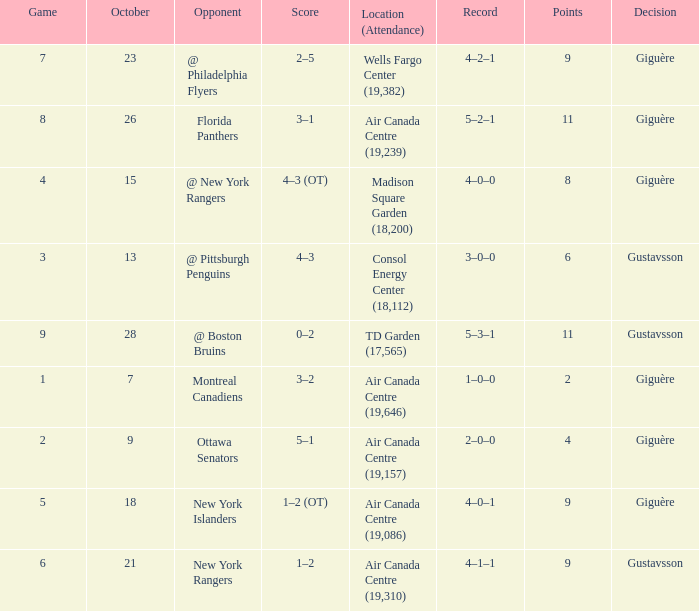What was the score for the opponent florida panthers? 1.0. 